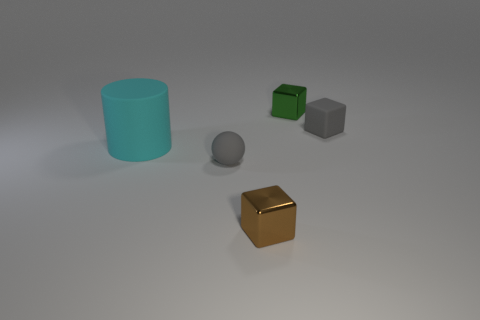Subtract all gray matte cubes. How many cubes are left? 2 Add 1 brown things. How many objects exist? 6 Subtract all brown blocks. How many blocks are left? 2 Subtract all blocks. How many objects are left? 2 Subtract 1 balls. How many balls are left? 0 Subtract all gray cylinders. Subtract all cyan spheres. How many cylinders are left? 1 Subtract all brown cylinders. How many gray blocks are left? 1 Subtract all gray blocks. Subtract all rubber cylinders. How many objects are left? 3 Add 3 big objects. How many big objects are left? 4 Add 1 tiny blue metal objects. How many tiny blue metal objects exist? 1 